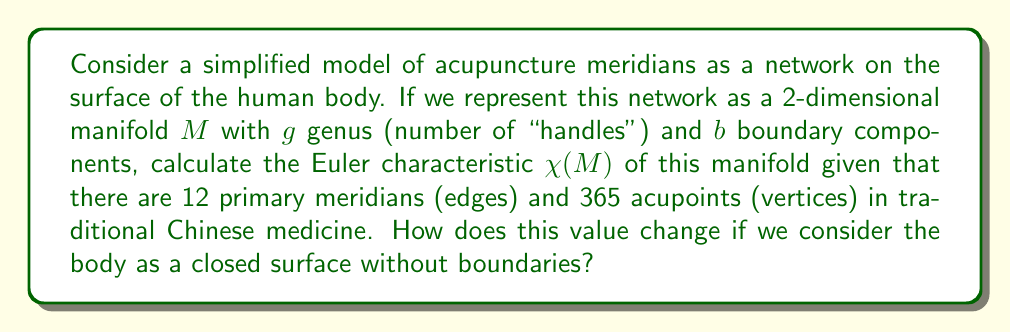Give your solution to this math problem. To solve this problem, we'll use the following steps:

1. Recall the formula for the Euler characteristic of a 2-dimensional manifold:
   $$\chi(M) = V - E + F$$
   where $V$ is the number of vertices, $E$ is the number of edges, and $F$ is the number of faces.

2. We're given that:
   - $V = 365$ (acupoints)
   - $E = 12$ (primary meridians)

3. For a 2-dimensional manifold with genus $g$ and $b$ boundary components, the Euler characteristic is also given by:
   $$\chi(M) = 2 - 2g - b$$

4. To find $F$, we can use the fact that the meridian network divides the surface into regions. The number of faces is related to the number of vertices and edges by the Euler characteristic formula.

5. Equating the two formulas for $\chi(M)$:
   $$V - E + F = 2 - 2g - b$$
   $$365 - 12 + F = 2 - 2g - b$$
   $$F = 2 - 2g - b - 353$$

6. The Euler characteristic is thus:
   $$\chi(M) = 365 - 12 + (2 - 2g - b - 353) = 2 - 2g - b$$

7. If we consider the body as a closed surface without boundaries, $b = 0$. The human body is topologically equivalent to a sphere, which has genus $g = 0$.

8. For a closed surface (sphere), the Euler characteristic becomes:
   $$\chi(M) = 2 - 2g - 0 = 2 - 2(0) = 2$$
Answer: The Euler characteristic of the manifold $M$ representing the acupuncture meridian network is $\chi(M) = 2 - 2g - b$, where $g$ is the genus and $b$ is the number of boundary components.

When considering the body as a closed surface without boundaries (topologically equivalent to a sphere), the Euler characteristic becomes $\chi(M) = 2$. 